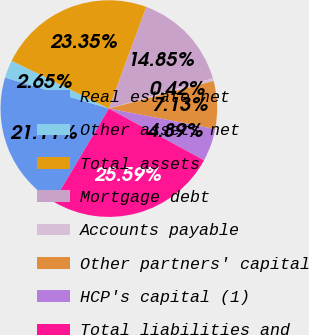<chart> <loc_0><loc_0><loc_500><loc_500><pie_chart><fcel>Real estate net<fcel>Other assets net<fcel>Total assets<fcel>Mortgage debt<fcel>Accounts payable<fcel>Other partners' capital<fcel>HCP's capital (1)<fcel>Total liabilities and<nl><fcel>21.11%<fcel>2.65%<fcel>23.35%<fcel>14.85%<fcel>0.42%<fcel>7.13%<fcel>4.89%<fcel>25.59%<nl></chart> 